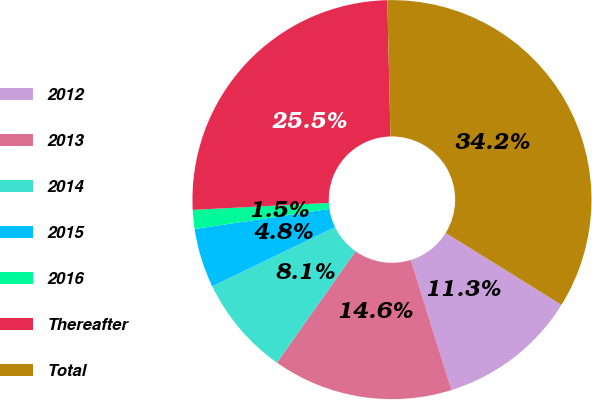Convert chart. <chart><loc_0><loc_0><loc_500><loc_500><pie_chart><fcel>2012<fcel>2013<fcel>2014<fcel>2015<fcel>2016<fcel>Thereafter<fcel>Total<nl><fcel>11.34%<fcel>14.6%<fcel>8.07%<fcel>4.8%<fcel>1.53%<fcel>25.45%<fcel>34.21%<nl></chart> 